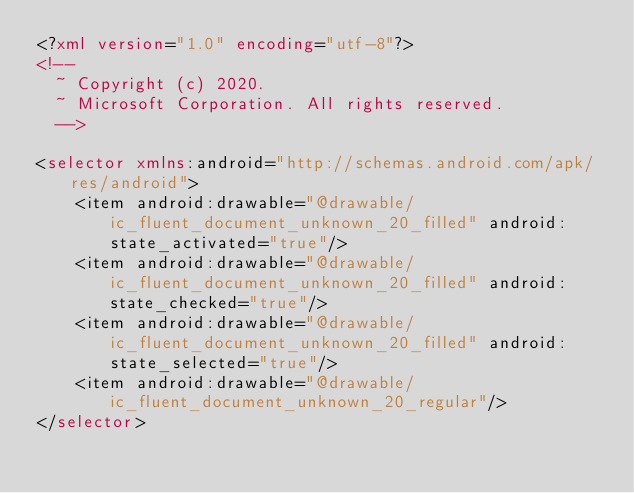Convert code to text. <code><loc_0><loc_0><loc_500><loc_500><_XML_><?xml version="1.0" encoding="utf-8"?>
<!--
  ~ Copyright (c) 2020.
  ~ Microsoft Corporation. All rights reserved.
  -->

<selector xmlns:android="http://schemas.android.com/apk/res/android">
    <item android:drawable="@drawable/ic_fluent_document_unknown_20_filled" android:state_activated="true"/>
    <item android:drawable="@drawable/ic_fluent_document_unknown_20_filled" android:state_checked="true"/>
    <item android:drawable="@drawable/ic_fluent_document_unknown_20_filled" android:state_selected="true"/>
    <item android:drawable="@drawable/ic_fluent_document_unknown_20_regular"/>
</selector>
</code> 